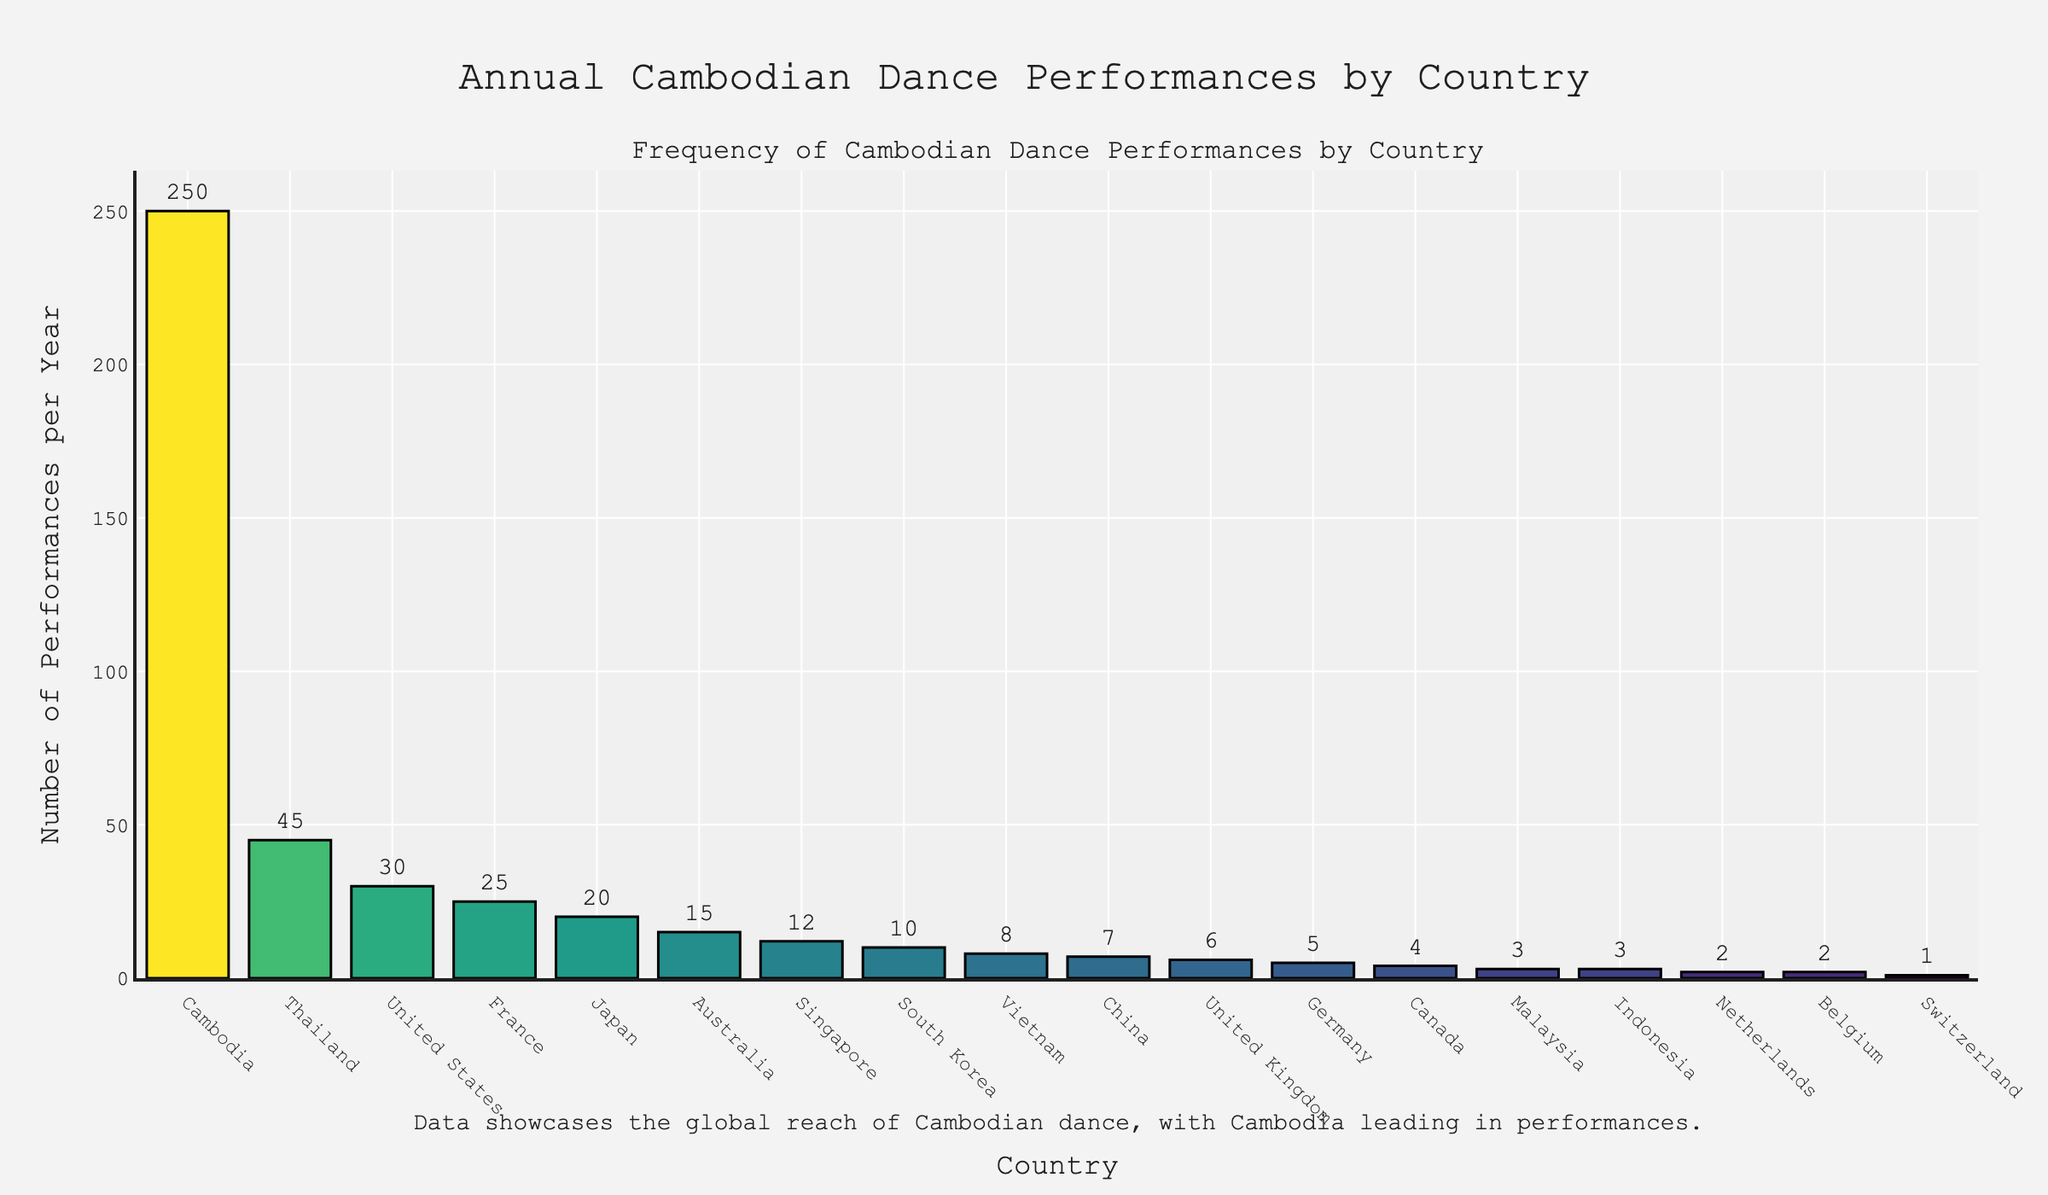Which country has the highest number of Cambodian dance performances per year? The chart shows the frequency of Cambodian dance performances by country, with Cambodia having the highest bar.
Answer: Cambodia How many more performances are held in Cambodia compared to Thailand per year? The number of performances in Cambodia is 250, and in Thailand, it is 45. The difference is 250 - 45 = 205.
Answer: 205 Which countries have fewer than 10 performances per year? The chart shows several countries with performance counts below 10: Vietnam (8), China (7), United Kingdom (6), Germany (5), Canada (4), Malaysia (3), Indonesia (3), Netherlands (2), Belgium (2), and Switzerland (1).
Answer: Vietnam, China, United Kingdom, Germany, Canada, Malaysia, Indonesia, Netherlands, Belgium, Switzerland What is the average number of performances per year across France, Japan, and Australia? France has 25 performances, Japan has 20, and Australia has 15. The sum is 25 + 20 + 15 = 60. To find the average, divide by 3: 60 / 3 = 20.
Answer: 20 How does the number of performances in Canada compare to Germany? The chart shows Canada with 4 performances and Germany with 5. Thus, Germany has 1 more performance than Canada.
Answer: Germany has 1 more performance than Canada What is the total number of performances per year in the United States, France, and Japan combined? Adding the number of performances in the United States (30), France (25), and Japan (20) results in a total of 30 + 25 + 20 = 75.
Answer: 75 Between Singapore and South Korea, which country has more performances and by how much? Singapore has 12 performances, while South Korea has 10. The difference is 12 - 10 = 2.
Answer: Singapore by 2 What is the total number of performances per year in European countries (France, United Kingdom, Germany, Netherlands, Belgium, Switzerland)? Adding the number of performances in each European country: France (25), United Kingdom (6), Germany (5), Netherlands (2), Belgium (2), Switzerland (1) results in 25 + 6 + 5 + 2 + 2 + 1 = 41.
Answer: 41 Which countries have a lighter shade of color but still show more than 10 performances per year? The bars for Thailand (45), United States (30), France (25), Japan (20), and Australia (15) show more than 10 performances per year and are lighter in shade compared to darker bars with fewer performances.
Answer: Thailand, United States, France, Japan, Australia 